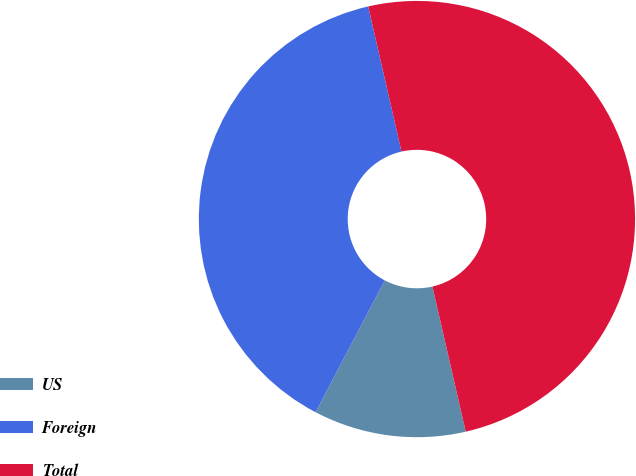<chart> <loc_0><loc_0><loc_500><loc_500><pie_chart><fcel>US<fcel>Foreign<fcel>Total<nl><fcel>11.28%<fcel>38.72%<fcel>50.0%<nl></chart> 